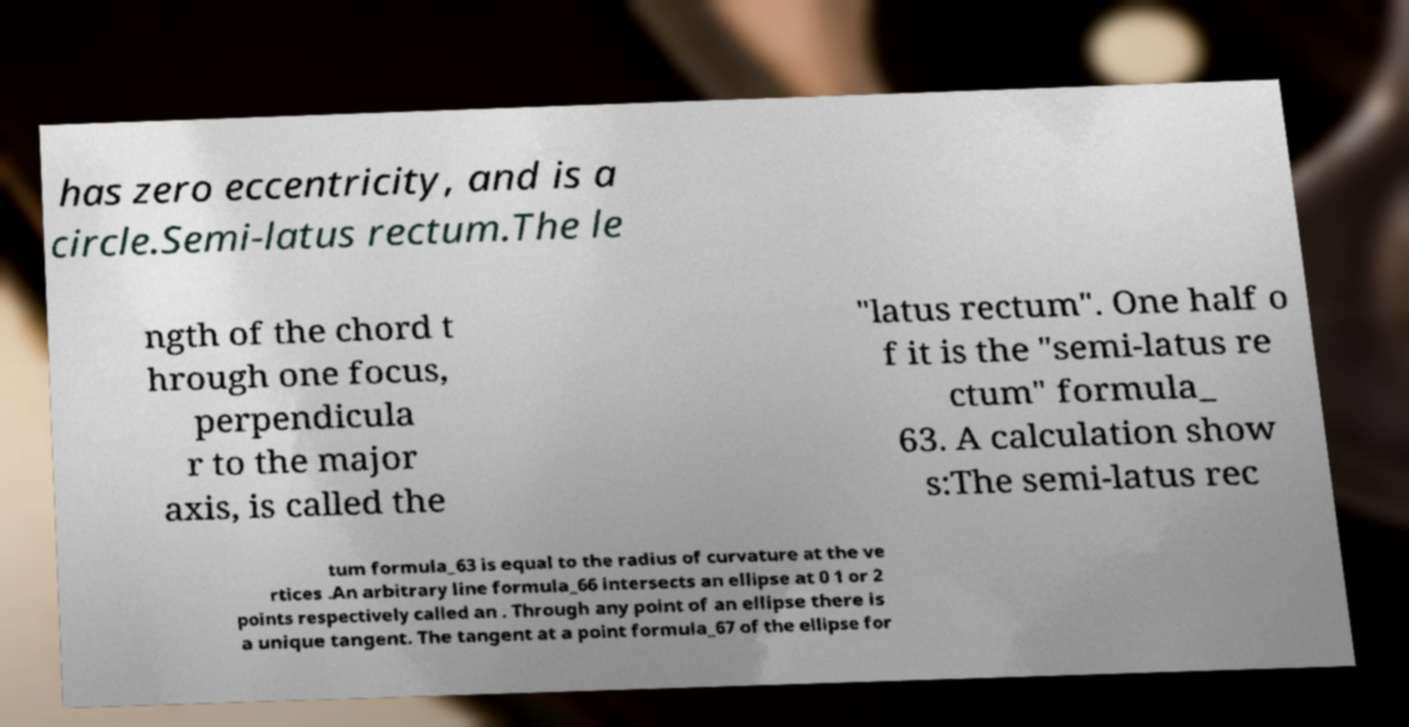Could you extract and type out the text from this image? has zero eccentricity, and is a circle.Semi-latus rectum.The le ngth of the chord t hrough one focus, perpendicula r to the major axis, is called the "latus rectum". One half o f it is the "semi-latus re ctum" formula_ 63. A calculation show s:The semi-latus rec tum formula_63 is equal to the radius of curvature at the ve rtices .An arbitrary line formula_66 intersects an ellipse at 0 1 or 2 points respectively called an . Through any point of an ellipse there is a unique tangent. The tangent at a point formula_67 of the ellipse for 